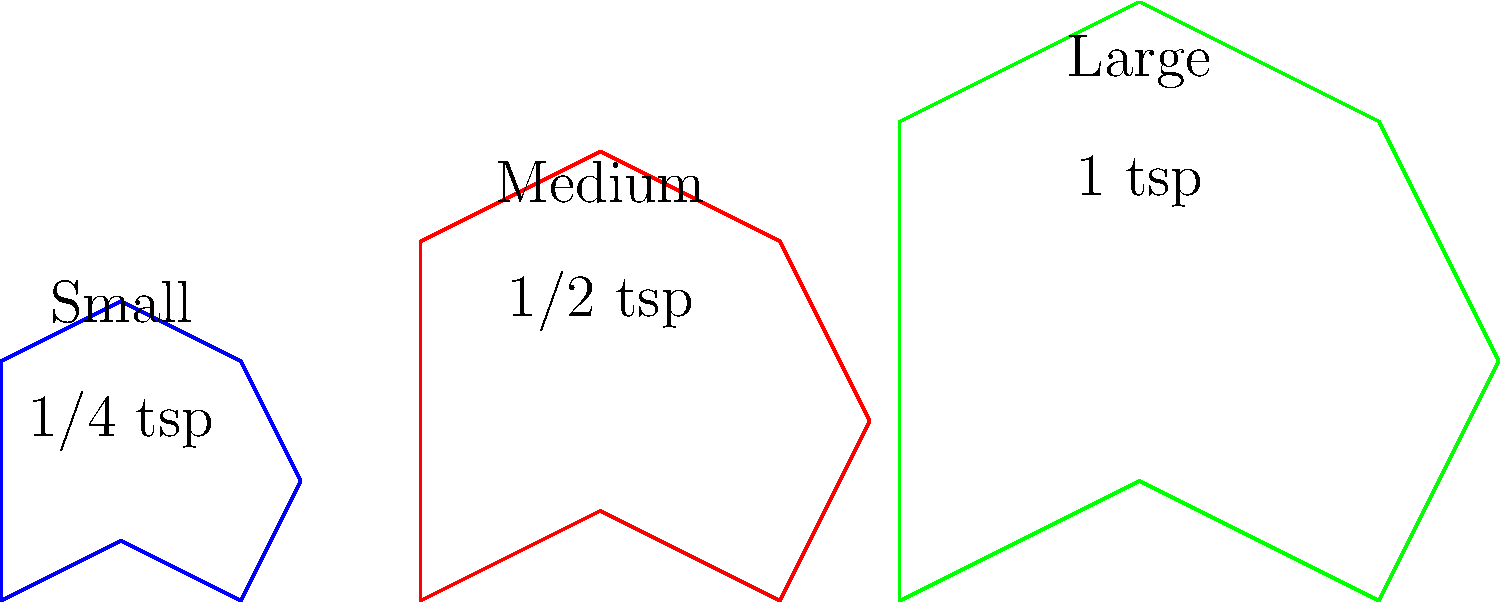Based on the silhouettes and recommended honey intake shown in the image, what is the maximum amount of honey (in teaspoons) that should be given to a medium-sized dog as part of their homemade treat recipe? To determine the maximum amount of honey for a medium-sized dog:

1. Observe the image, which shows three dog silhouettes representing small, medium, and large dogs.
2. Each silhouette is associated with a recommended honey intake.
3. For the medium-sized dog (red silhouette in the middle):
   - The label indicates "1/2 tsp" of honey.
4. This measurement represents the maximum recommended amount for a medium-sized dog.
5. It's important to note that this is a general guideline, and individual dogs may have different tolerances or dietary restrictions.
6. Always consult with a veterinarian before introducing new ingredients to your dog's diet.

Therefore, the maximum amount of honey recommended for a medium-sized dog in homemade treats is 1/2 teaspoon.
Answer: 1/2 teaspoon 